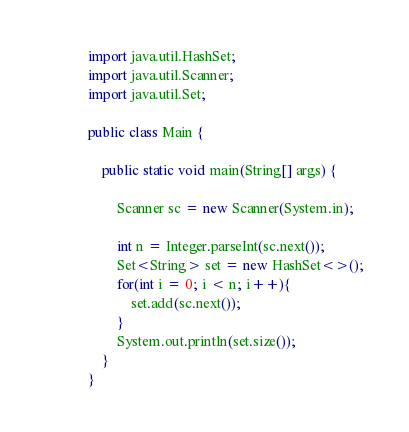Convert code to text. <code><loc_0><loc_0><loc_500><loc_500><_Java_>import java.util.HashSet;
import java.util.Scanner;
import java.util.Set;

public class Main {

    public static void main(String[] args) {
        
        Scanner sc = new Scanner(System.in);
        
        int n = Integer.parseInt(sc.next());
        Set<String> set = new HashSet<>();
        for(int i = 0; i < n; i++){
            set.add(sc.next());
        }
        System.out.println(set.size());
    }
}</code> 